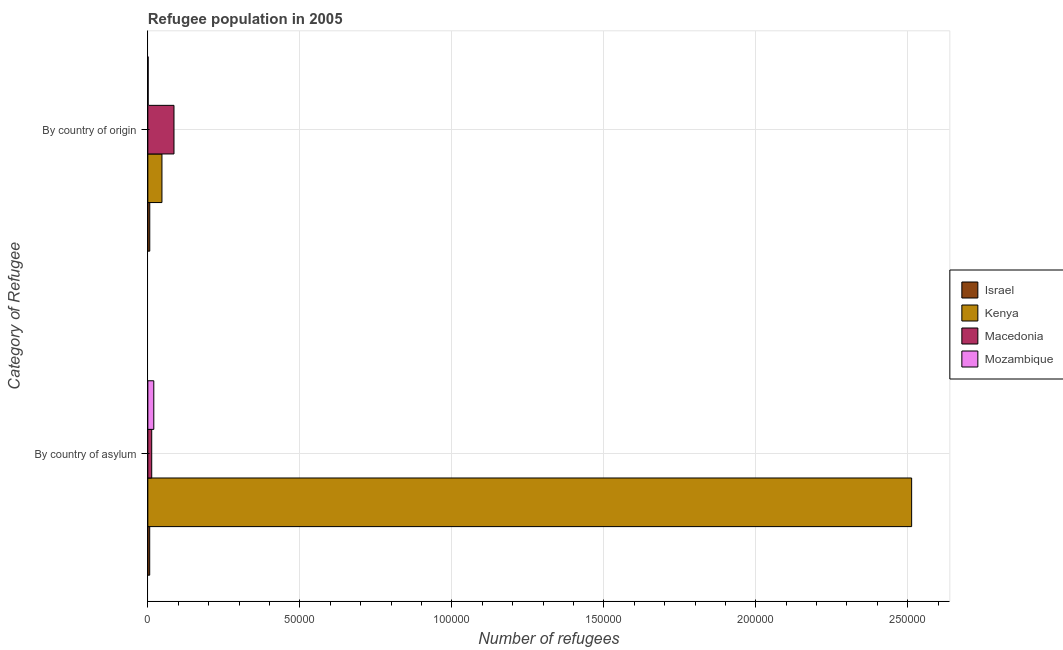How many groups of bars are there?
Provide a short and direct response. 2. Are the number of bars per tick equal to the number of legend labels?
Keep it short and to the point. Yes. Are the number of bars on each tick of the Y-axis equal?
Give a very brief answer. Yes. How many bars are there on the 1st tick from the top?
Ensure brevity in your answer.  4. What is the label of the 2nd group of bars from the top?
Your response must be concise. By country of asylum. What is the number of refugees by country of asylum in Mozambique?
Make the answer very short. 1954. Across all countries, what is the maximum number of refugees by country of asylum?
Provide a short and direct response. 2.51e+05. Across all countries, what is the minimum number of refugees by country of origin?
Offer a terse response. 104. In which country was the number of refugees by country of origin maximum?
Offer a terse response. Macedonia. In which country was the number of refugees by country of origin minimum?
Ensure brevity in your answer.  Mozambique. What is the total number of refugees by country of origin in the graph?
Ensure brevity in your answer.  1.40e+04. What is the difference between the number of refugees by country of asylum in Kenya and that in Mozambique?
Keep it short and to the point. 2.49e+05. What is the difference between the number of refugees by country of origin in Mozambique and the number of refugees by country of asylum in Macedonia?
Keep it short and to the point. -1170. What is the average number of refugees by country of asylum per country?
Offer a terse response. 6.38e+04. What is the difference between the number of refugees by country of origin and number of refugees by country of asylum in Kenya?
Make the answer very short. -2.47e+05. What is the ratio of the number of refugees by country of origin in Mozambique to that in Israel?
Provide a short and direct response. 0.16. Is the number of refugees by country of asylum in Israel less than that in Mozambique?
Your response must be concise. Yes. In how many countries, is the number of refugees by country of origin greater than the average number of refugees by country of origin taken over all countries?
Make the answer very short. 2. What does the 3rd bar from the bottom in By country of asylum represents?
Ensure brevity in your answer.  Macedonia. What is the difference between two consecutive major ticks on the X-axis?
Make the answer very short. 5.00e+04. Are the values on the major ticks of X-axis written in scientific E-notation?
Provide a short and direct response. No. Does the graph contain any zero values?
Ensure brevity in your answer.  No. How many legend labels are there?
Provide a short and direct response. 4. What is the title of the graph?
Ensure brevity in your answer.  Refugee population in 2005. Does "Spain" appear as one of the legend labels in the graph?
Give a very brief answer. No. What is the label or title of the X-axis?
Make the answer very short. Number of refugees. What is the label or title of the Y-axis?
Ensure brevity in your answer.  Category of Refugee. What is the Number of refugees of Israel in By country of asylum?
Keep it short and to the point. 609. What is the Number of refugees in Kenya in By country of asylum?
Ensure brevity in your answer.  2.51e+05. What is the Number of refugees of Macedonia in By country of asylum?
Your answer should be compact. 1274. What is the Number of refugees in Mozambique in By country of asylum?
Your answer should be compact. 1954. What is the Number of refugees in Israel in By country of origin?
Give a very brief answer. 632. What is the Number of refugees of Kenya in By country of origin?
Provide a short and direct response. 4640. What is the Number of refugees of Macedonia in By country of origin?
Offer a very short reply. 8600. What is the Number of refugees in Mozambique in By country of origin?
Your response must be concise. 104. Across all Category of Refugee, what is the maximum Number of refugees of Israel?
Offer a terse response. 632. Across all Category of Refugee, what is the maximum Number of refugees of Kenya?
Offer a terse response. 2.51e+05. Across all Category of Refugee, what is the maximum Number of refugees in Macedonia?
Your response must be concise. 8600. Across all Category of Refugee, what is the maximum Number of refugees of Mozambique?
Offer a terse response. 1954. Across all Category of Refugee, what is the minimum Number of refugees in Israel?
Keep it short and to the point. 609. Across all Category of Refugee, what is the minimum Number of refugees of Kenya?
Keep it short and to the point. 4640. Across all Category of Refugee, what is the minimum Number of refugees of Macedonia?
Offer a terse response. 1274. Across all Category of Refugee, what is the minimum Number of refugees in Mozambique?
Your answer should be very brief. 104. What is the total Number of refugees of Israel in the graph?
Offer a terse response. 1241. What is the total Number of refugees in Kenya in the graph?
Provide a succinct answer. 2.56e+05. What is the total Number of refugees in Macedonia in the graph?
Provide a short and direct response. 9874. What is the total Number of refugees of Mozambique in the graph?
Provide a short and direct response. 2058. What is the difference between the Number of refugees of Kenya in By country of asylum and that in By country of origin?
Ensure brevity in your answer.  2.47e+05. What is the difference between the Number of refugees in Macedonia in By country of asylum and that in By country of origin?
Provide a succinct answer. -7326. What is the difference between the Number of refugees in Mozambique in By country of asylum and that in By country of origin?
Give a very brief answer. 1850. What is the difference between the Number of refugees of Israel in By country of asylum and the Number of refugees of Kenya in By country of origin?
Your answer should be compact. -4031. What is the difference between the Number of refugees in Israel in By country of asylum and the Number of refugees in Macedonia in By country of origin?
Offer a terse response. -7991. What is the difference between the Number of refugees in Israel in By country of asylum and the Number of refugees in Mozambique in By country of origin?
Provide a short and direct response. 505. What is the difference between the Number of refugees in Kenya in By country of asylum and the Number of refugees in Macedonia in By country of origin?
Give a very brief answer. 2.43e+05. What is the difference between the Number of refugees in Kenya in By country of asylum and the Number of refugees in Mozambique in By country of origin?
Your response must be concise. 2.51e+05. What is the difference between the Number of refugees in Macedonia in By country of asylum and the Number of refugees in Mozambique in By country of origin?
Offer a very short reply. 1170. What is the average Number of refugees of Israel per Category of Refugee?
Make the answer very short. 620.5. What is the average Number of refugees in Kenya per Category of Refugee?
Offer a very short reply. 1.28e+05. What is the average Number of refugees of Macedonia per Category of Refugee?
Give a very brief answer. 4937. What is the average Number of refugees of Mozambique per Category of Refugee?
Provide a short and direct response. 1029. What is the difference between the Number of refugees in Israel and Number of refugees in Kenya in By country of asylum?
Provide a short and direct response. -2.51e+05. What is the difference between the Number of refugees of Israel and Number of refugees of Macedonia in By country of asylum?
Give a very brief answer. -665. What is the difference between the Number of refugees in Israel and Number of refugees in Mozambique in By country of asylum?
Provide a succinct answer. -1345. What is the difference between the Number of refugees of Kenya and Number of refugees of Macedonia in By country of asylum?
Make the answer very short. 2.50e+05. What is the difference between the Number of refugees of Kenya and Number of refugees of Mozambique in By country of asylum?
Offer a terse response. 2.49e+05. What is the difference between the Number of refugees in Macedonia and Number of refugees in Mozambique in By country of asylum?
Keep it short and to the point. -680. What is the difference between the Number of refugees of Israel and Number of refugees of Kenya in By country of origin?
Your answer should be very brief. -4008. What is the difference between the Number of refugees of Israel and Number of refugees of Macedonia in By country of origin?
Provide a short and direct response. -7968. What is the difference between the Number of refugees in Israel and Number of refugees in Mozambique in By country of origin?
Make the answer very short. 528. What is the difference between the Number of refugees in Kenya and Number of refugees in Macedonia in By country of origin?
Make the answer very short. -3960. What is the difference between the Number of refugees in Kenya and Number of refugees in Mozambique in By country of origin?
Give a very brief answer. 4536. What is the difference between the Number of refugees of Macedonia and Number of refugees of Mozambique in By country of origin?
Your answer should be compact. 8496. What is the ratio of the Number of refugees of Israel in By country of asylum to that in By country of origin?
Provide a short and direct response. 0.96. What is the ratio of the Number of refugees in Kenya in By country of asylum to that in By country of origin?
Make the answer very short. 54.15. What is the ratio of the Number of refugees in Macedonia in By country of asylum to that in By country of origin?
Your answer should be very brief. 0.15. What is the ratio of the Number of refugees in Mozambique in By country of asylum to that in By country of origin?
Provide a succinct answer. 18.79. What is the difference between the highest and the second highest Number of refugees of Israel?
Ensure brevity in your answer.  23. What is the difference between the highest and the second highest Number of refugees in Kenya?
Offer a very short reply. 2.47e+05. What is the difference between the highest and the second highest Number of refugees in Macedonia?
Your answer should be very brief. 7326. What is the difference between the highest and the second highest Number of refugees of Mozambique?
Your answer should be compact. 1850. What is the difference between the highest and the lowest Number of refugees of Israel?
Make the answer very short. 23. What is the difference between the highest and the lowest Number of refugees in Kenya?
Your answer should be compact. 2.47e+05. What is the difference between the highest and the lowest Number of refugees of Macedonia?
Make the answer very short. 7326. What is the difference between the highest and the lowest Number of refugees in Mozambique?
Offer a very short reply. 1850. 